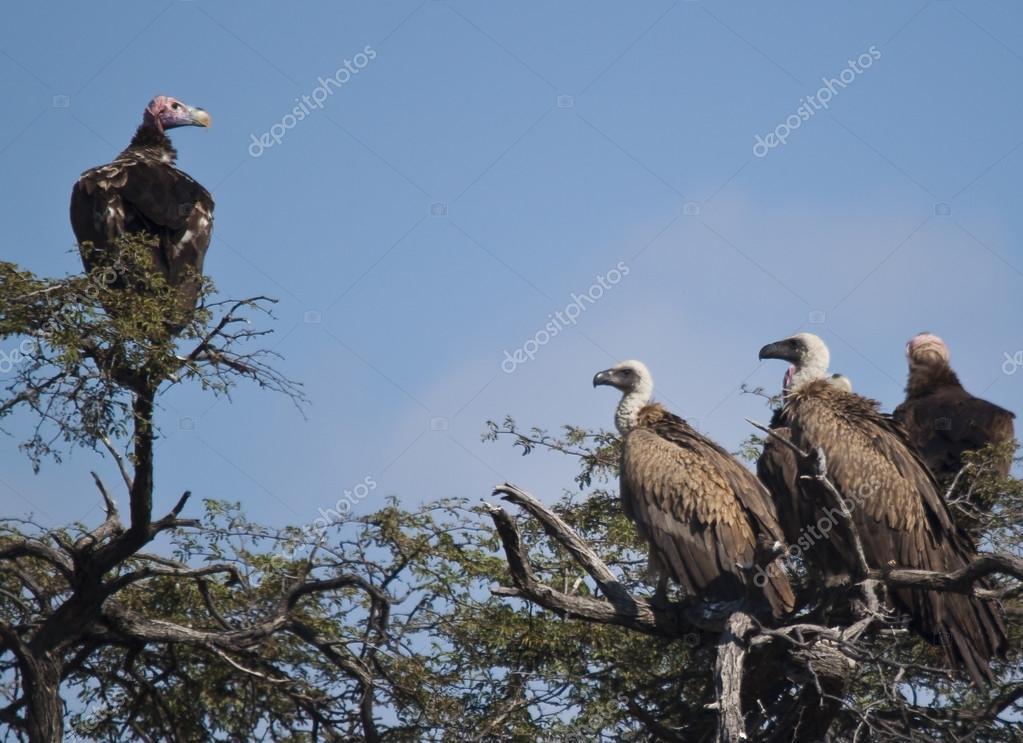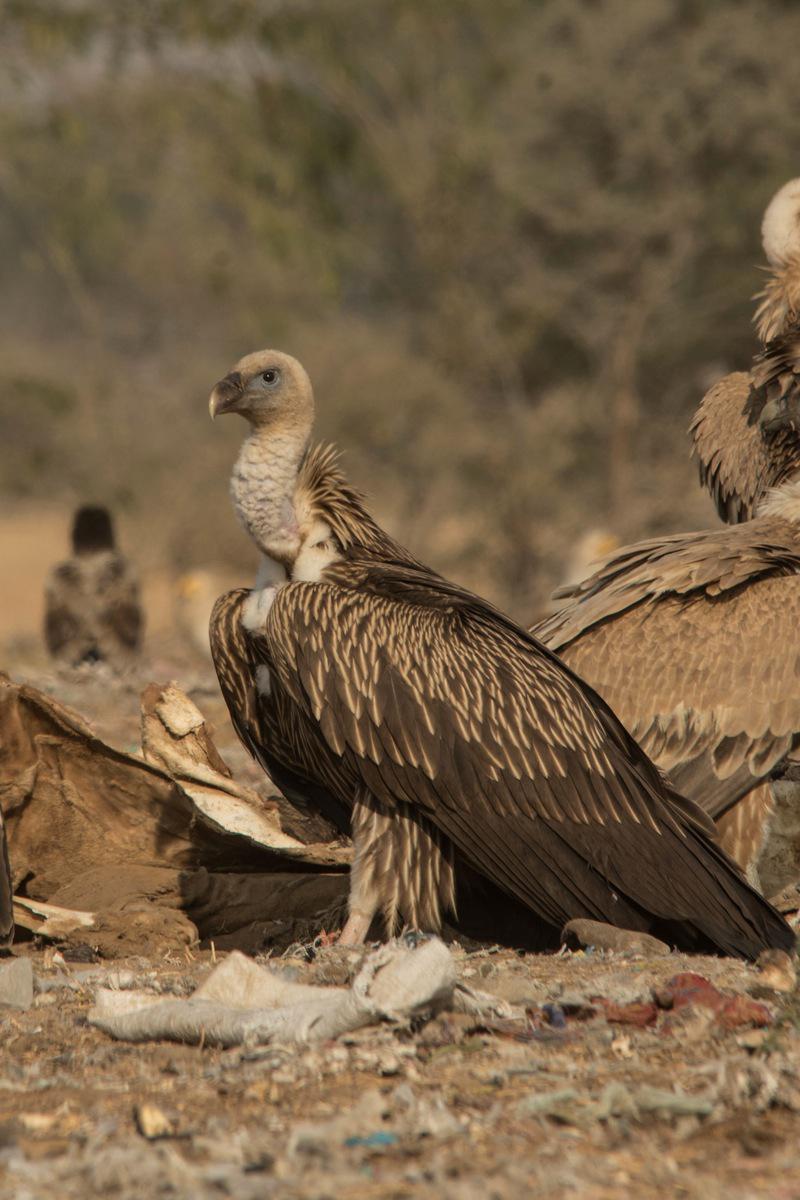The first image is the image on the left, the second image is the image on the right. Given the left and right images, does the statement "The bird in the image on the left has its wings spread wide." hold true? Answer yes or no. No. 